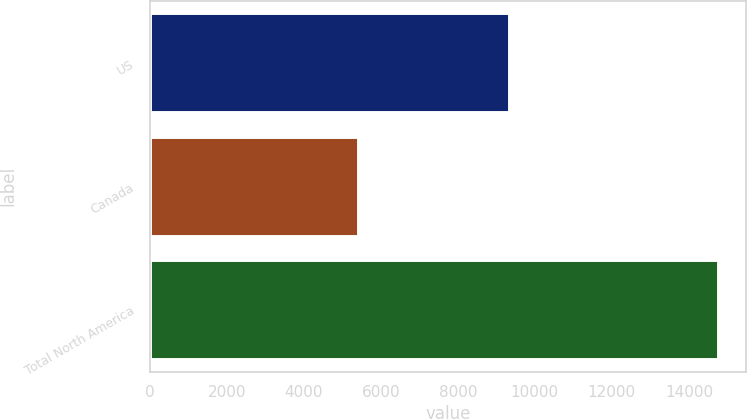<chart> <loc_0><loc_0><loc_500><loc_500><bar_chart><fcel>US<fcel>Canada<fcel>Total North America<nl><fcel>9328<fcel>5416<fcel>14744<nl></chart> 